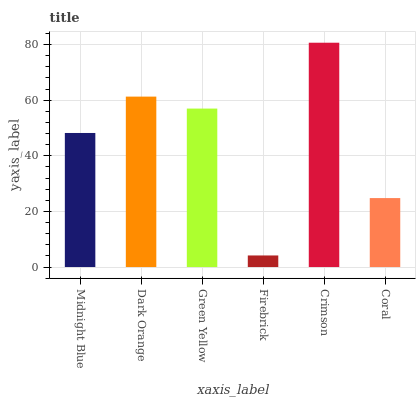Is Firebrick the minimum?
Answer yes or no. Yes. Is Crimson the maximum?
Answer yes or no. Yes. Is Dark Orange the minimum?
Answer yes or no. No. Is Dark Orange the maximum?
Answer yes or no. No. Is Dark Orange greater than Midnight Blue?
Answer yes or no. Yes. Is Midnight Blue less than Dark Orange?
Answer yes or no. Yes. Is Midnight Blue greater than Dark Orange?
Answer yes or no. No. Is Dark Orange less than Midnight Blue?
Answer yes or no. No. Is Green Yellow the high median?
Answer yes or no. Yes. Is Midnight Blue the low median?
Answer yes or no. Yes. Is Dark Orange the high median?
Answer yes or no. No. Is Dark Orange the low median?
Answer yes or no. No. 